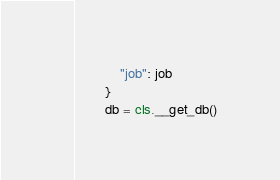<code> <loc_0><loc_0><loc_500><loc_500><_Python_>            "job": job
        }
        db = cls.__get_db()</code> 